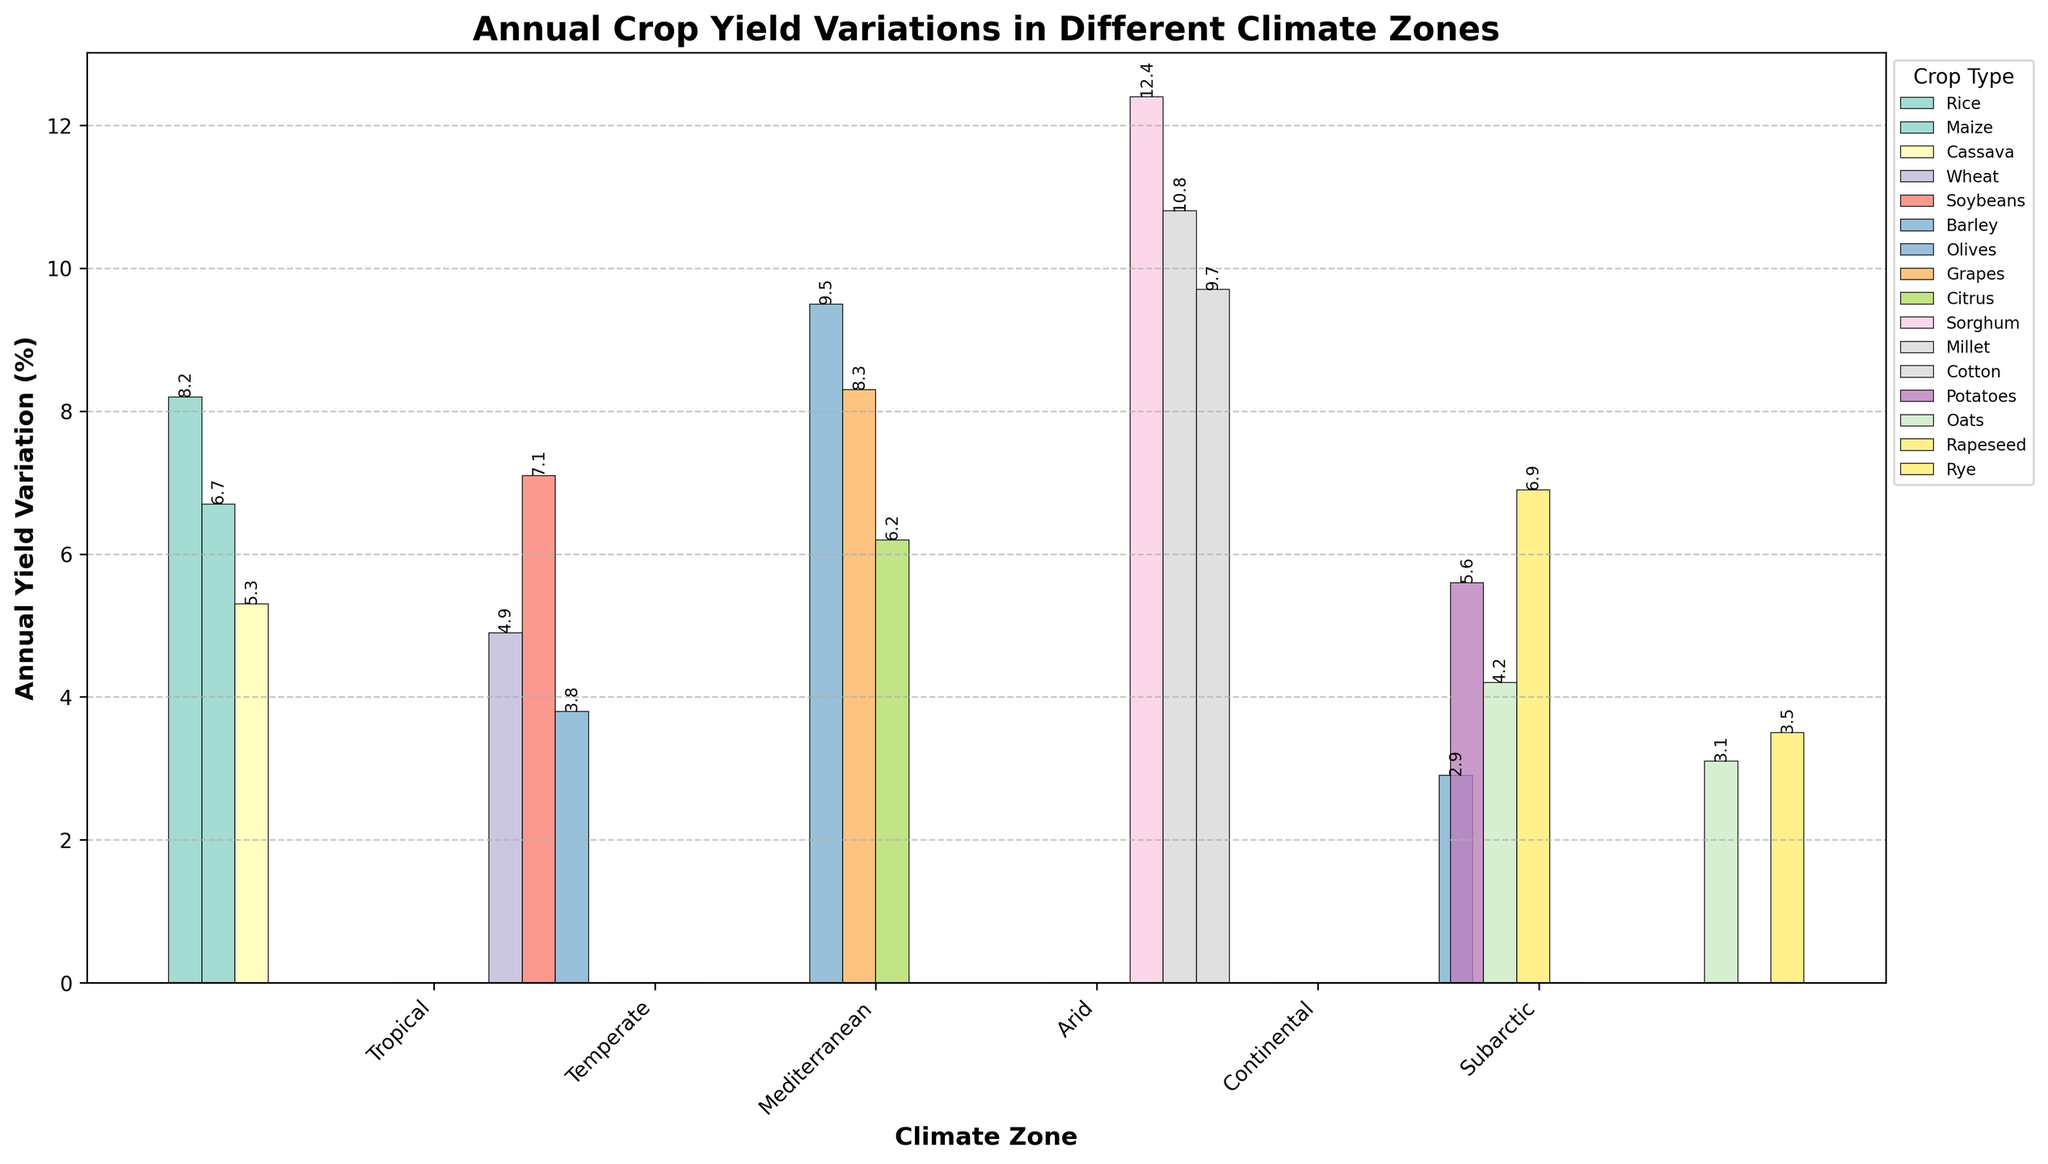Which climate zone has the highest annual crop yield variation for any crop type? The Mediterranean climate zone has the highest annual yield variation at 9.5% for olives. This is identified by comparing the heights of all the bars and noting that the tallest bar, representing olives in the Mediterranean, reaches 9.5%.
Answer: Mediterranean Which crop type shows the highest annual yield variation in the Arid climate zone? In the Arid climate zone, sorghum exhibits the highest yield variation at 12.4%. This is determined by comparing the height of each bar for the crops within the Arid zone and noting that the tallest bar represents sorghum.
Answer: Sorghum What is the average annual yield variation for crops in the Temperate climate zone? To calculate the average, sum the yield variations for wheat (4.9%), soybeans (7.1%), and barley (3.8%) which equals 15.8%. Divide by the number of crops, which is 3: 15.8 / 3 = 5.27%.
Answer: 5.27% Is the annual yield variation for grapes in the Mediterranean climate zone higher than for maize in the Tropical climate zone? Grapes in the Mediterranean climate zone have an annual yield variation of 8.3%, while maize in the Tropical climate zone has 6.7%. Since 8.3% is greater than 6.7%, grapes in the Mediterranean have a higher yield variation.
Answer: Yes Which crop type has the smallest variation in the Subarctic climate zone? In the Subarctic climate zone, barley has the smallest yield variation at 2.9%. This is found by comparing the height of each bar for the crops within the Subarctic zone and noting that the shortest bar represents barley.
Answer: Barley What is the combined yield variation for all crop types in the Tropical climate zone? Add the yield variations for rice (8.2%), maize (6.7%), and cassava (5.3%) to get a total of 8.2 + 6.7 + 5.3 = 20.2%.
Answer: 20.2% Which climate zone has the most consistently low yield variations (considering the lowest variation among crops in each zone)? The Subarctic climate zone has the most consistently low yield variations, with the lowest variation being 2.9% for barley. This is determined by comparing the lowest variation in each climate zone and finding that 2.9% is the lowest among them.
Answer: Subarctic 